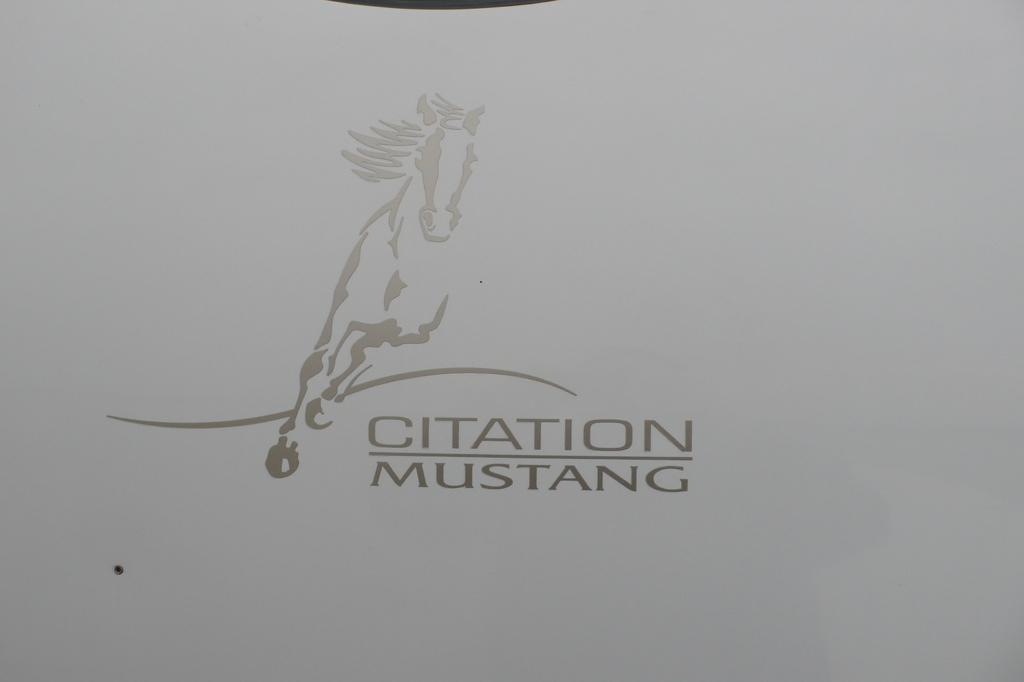What is the main subject of the image? The main subject of the image is a horse running. What else can be seen in the image besides the horse? There is text in the image. What is the color of the background in the image? The background of the image is white. How many dolls are distributed in the territory shown in the image? There are no dolls or territory mentioned in the image; it features a horse running and text on a white background. 